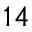<formula> <loc_0><loc_0><loc_500><loc_500>1 4</formula> 